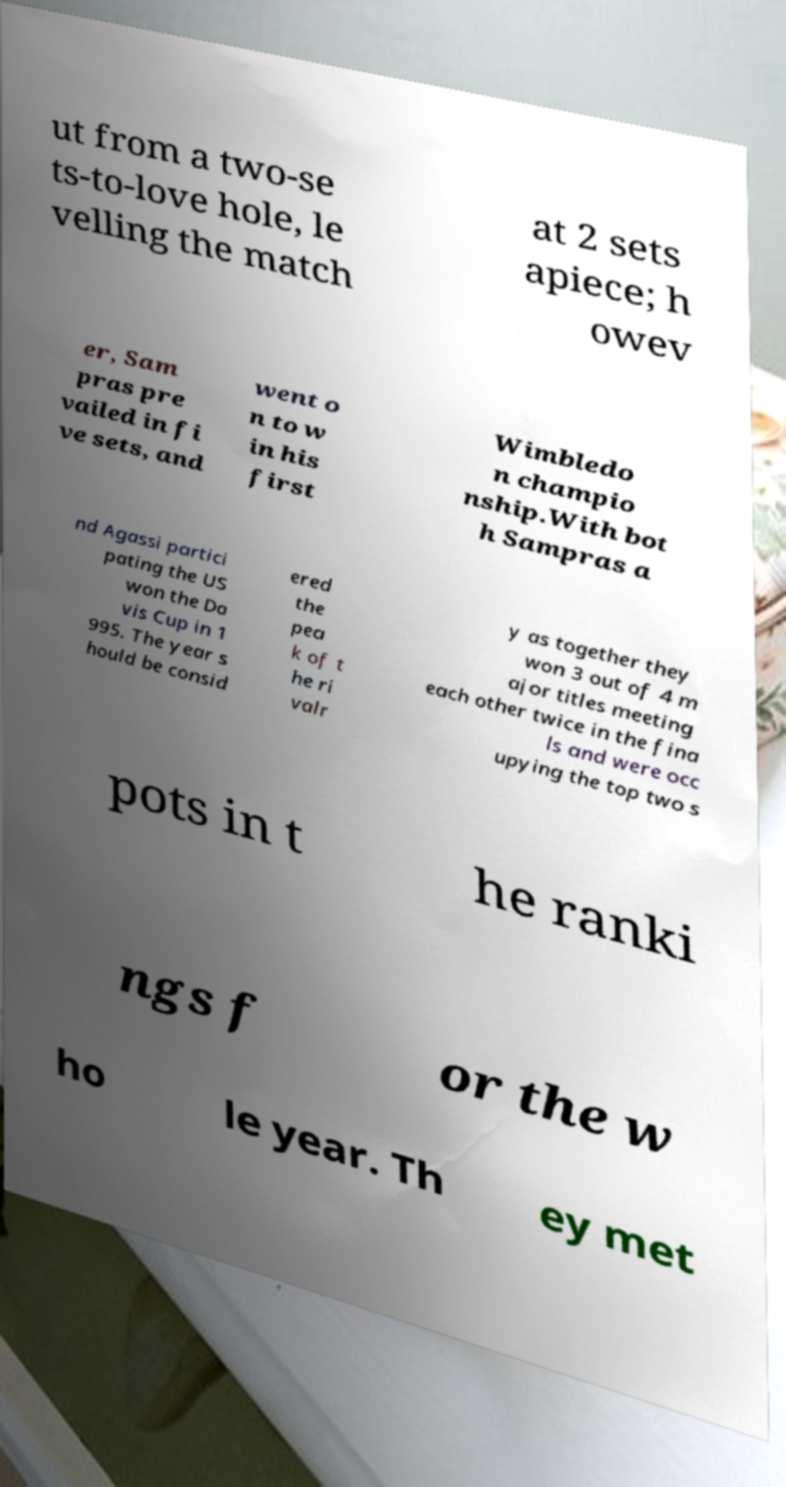There's text embedded in this image that I need extracted. Can you transcribe it verbatim? ut from a two-se ts-to-love hole, le velling the match at 2 sets apiece; h owev er, Sam pras pre vailed in fi ve sets, and went o n to w in his first Wimbledo n champio nship.With bot h Sampras a nd Agassi partici pating the US won the Da vis Cup in 1 995. The year s hould be consid ered the pea k of t he ri valr y as together they won 3 out of 4 m ajor titles meeting each other twice in the fina ls and were occ upying the top two s pots in t he ranki ngs f or the w ho le year. Th ey met 